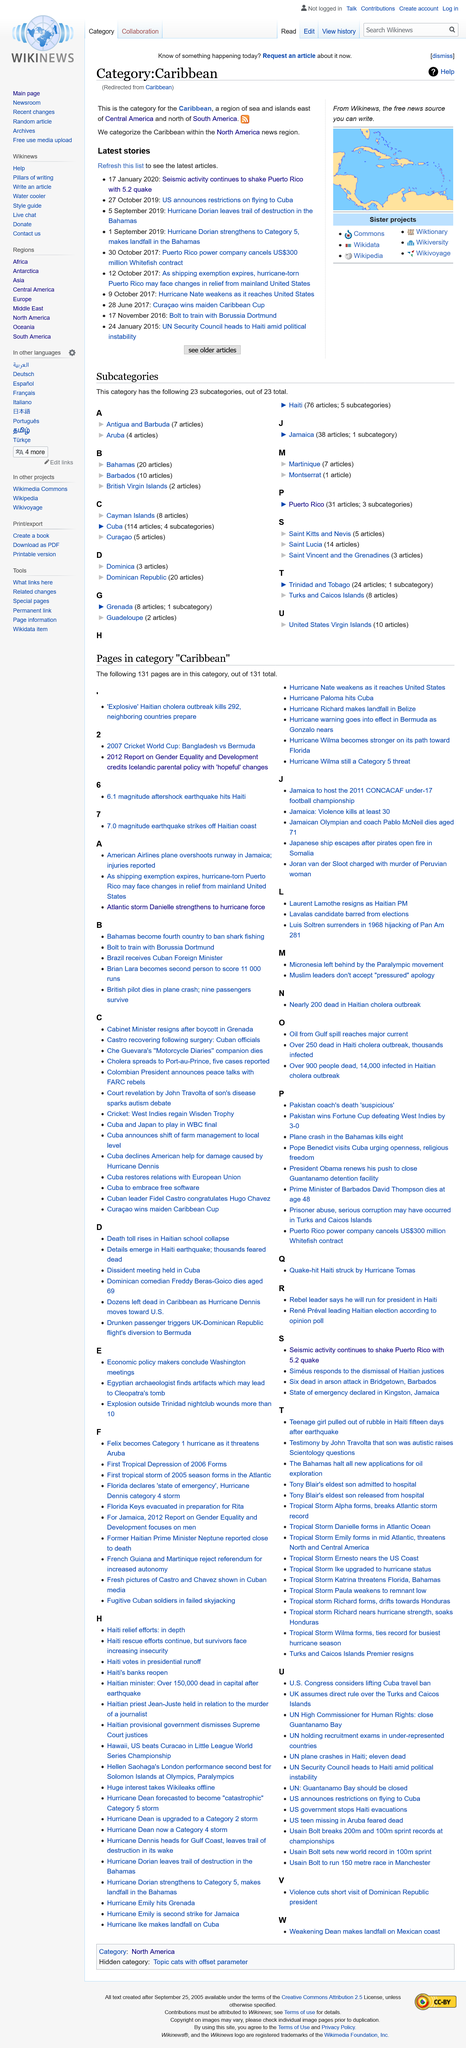List a handful of essential elements in this visual. The Caribbean islands are located in the eastern region of Central America and the northern region of South America. Hurricane Dorian was the name of the hurricane that made landfall in the Bahamas on 1st September 2019. The latest story on this page is titled "Seismic activity continues to shake Puerto Rico with 5.2 quake". 